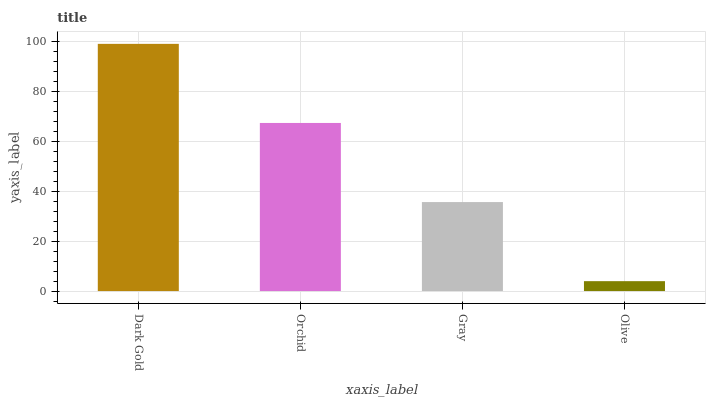Is Olive the minimum?
Answer yes or no. Yes. Is Dark Gold the maximum?
Answer yes or no. Yes. Is Orchid the minimum?
Answer yes or no. No. Is Orchid the maximum?
Answer yes or no. No. Is Dark Gold greater than Orchid?
Answer yes or no. Yes. Is Orchid less than Dark Gold?
Answer yes or no. Yes. Is Orchid greater than Dark Gold?
Answer yes or no. No. Is Dark Gold less than Orchid?
Answer yes or no. No. Is Orchid the high median?
Answer yes or no. Yes. Is Gray the low median?
Answer yes or no. Yes. Is Dark Gold the high median?
Answer yes or no. No. Is Olive the low median?
Answer yes or no. No. 